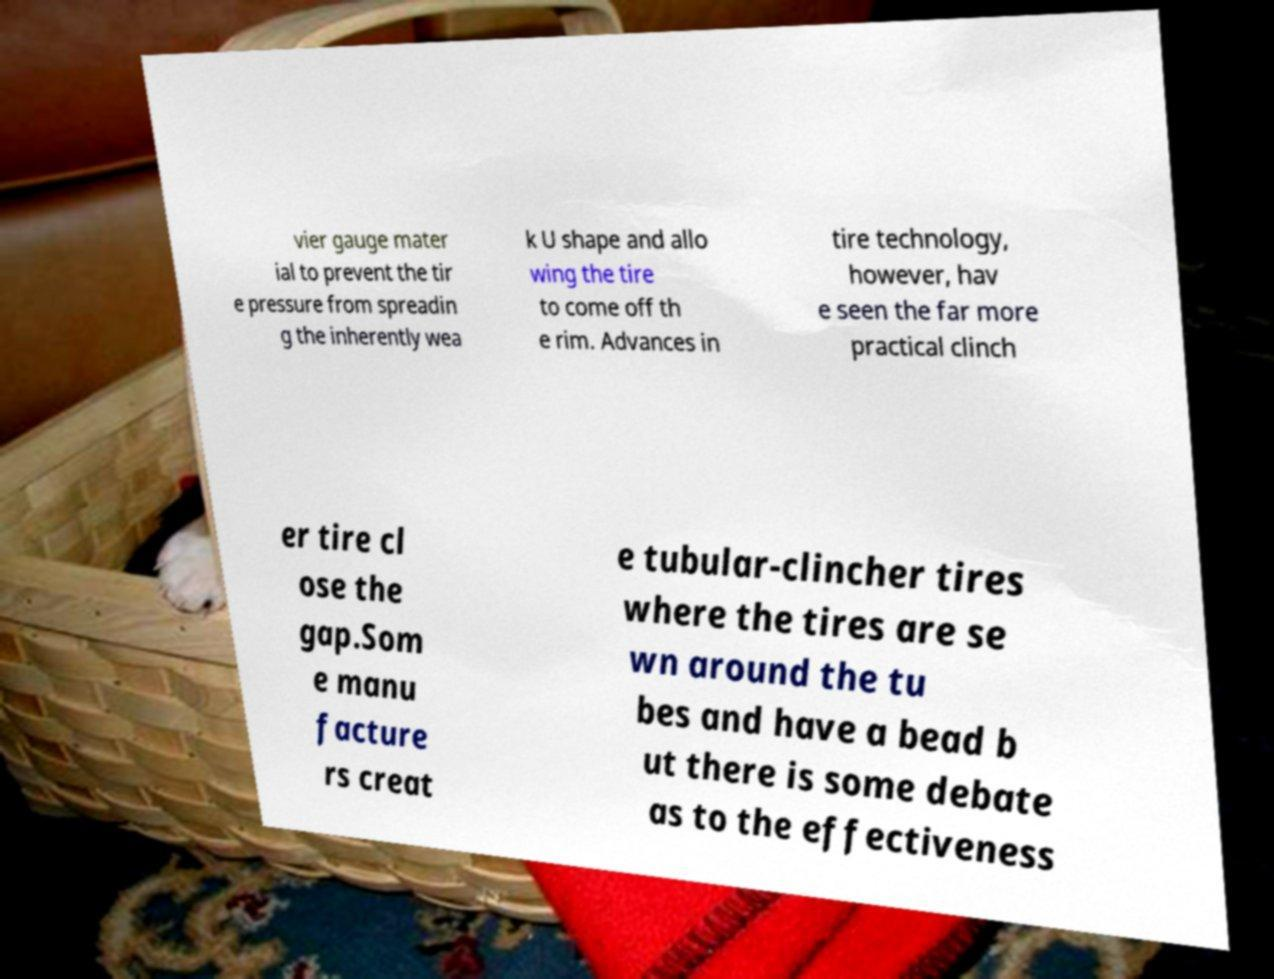Please identify and transcribe the text found in this image. vier gauge mater ial to prevent the tir e pressure from spreadin g the inherently wea k U shape and allo wing the tire to come off th e rim. Advances in tire technology, however, hav e seen the far more practical clinch er tire cl ose the gap.Som e manu facture rs creat e tubular-clincher tires where the tires are se wn around the tu bes and have a bead b ut there is some debate as to the effectiveness 